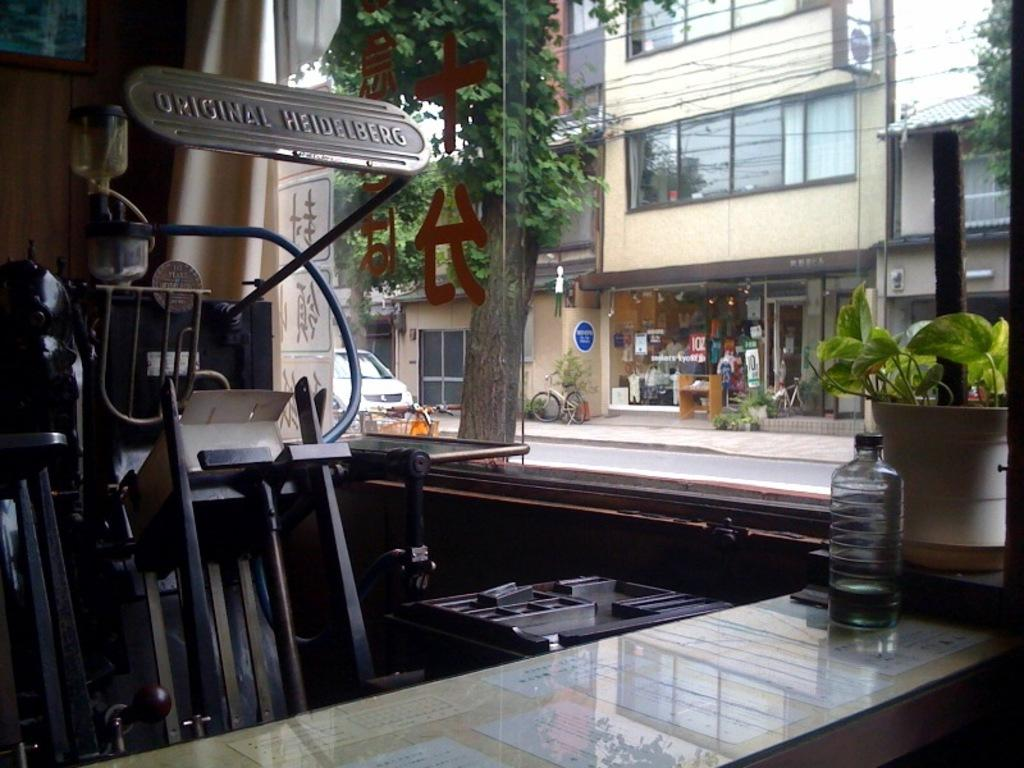Provide a one-sentence caption for the provided image. a shop with a machine in it titled ' original heidelberg'. 